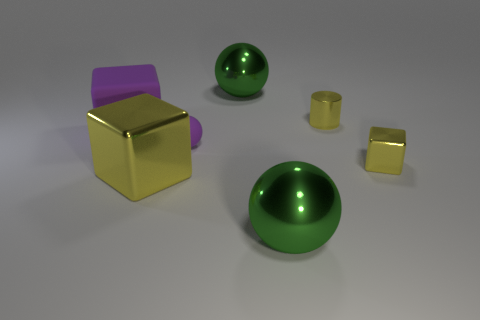Is the large purple cube made of the same material as the tiny yellow block?
Offer a terse response. No. The matte object that is the same size as the cylinder is what color?
Keep it short and to the point. Purple. There is a big sphere that is behind the tiny metallic cylinder; how many yellow cylinders are on the right side of it?
Provide a succinct answer. 1. How many yellow metallic objects are on the left side of the tiny purple rubber sphere and behind the purple rubber block?
Keep it short and to the point. 0. What number of things are yellow things that are in front of the small metallic cube or objects that are to the right of the large purple matte object?
Provide a succinct answer. 6. What number of other objects are there of the same size as the purple matte cube?
Your answer should be very brief. 3. There is a metal thing that is left of the metal sphere behind the small shiny cylinder; what is its shape?
Provide a succinct answer. Cube. There is a cylinder that is on the right side of the rubber ball; is its color the same as the small cube behind the large yellow block?
Keep it short and to the point. Yes. Are there any other things that have the same color as the small rubber ball?
Offer a very short reply. Yes. What color is the metal cylinder?
Make the answer very short. Yellow. 